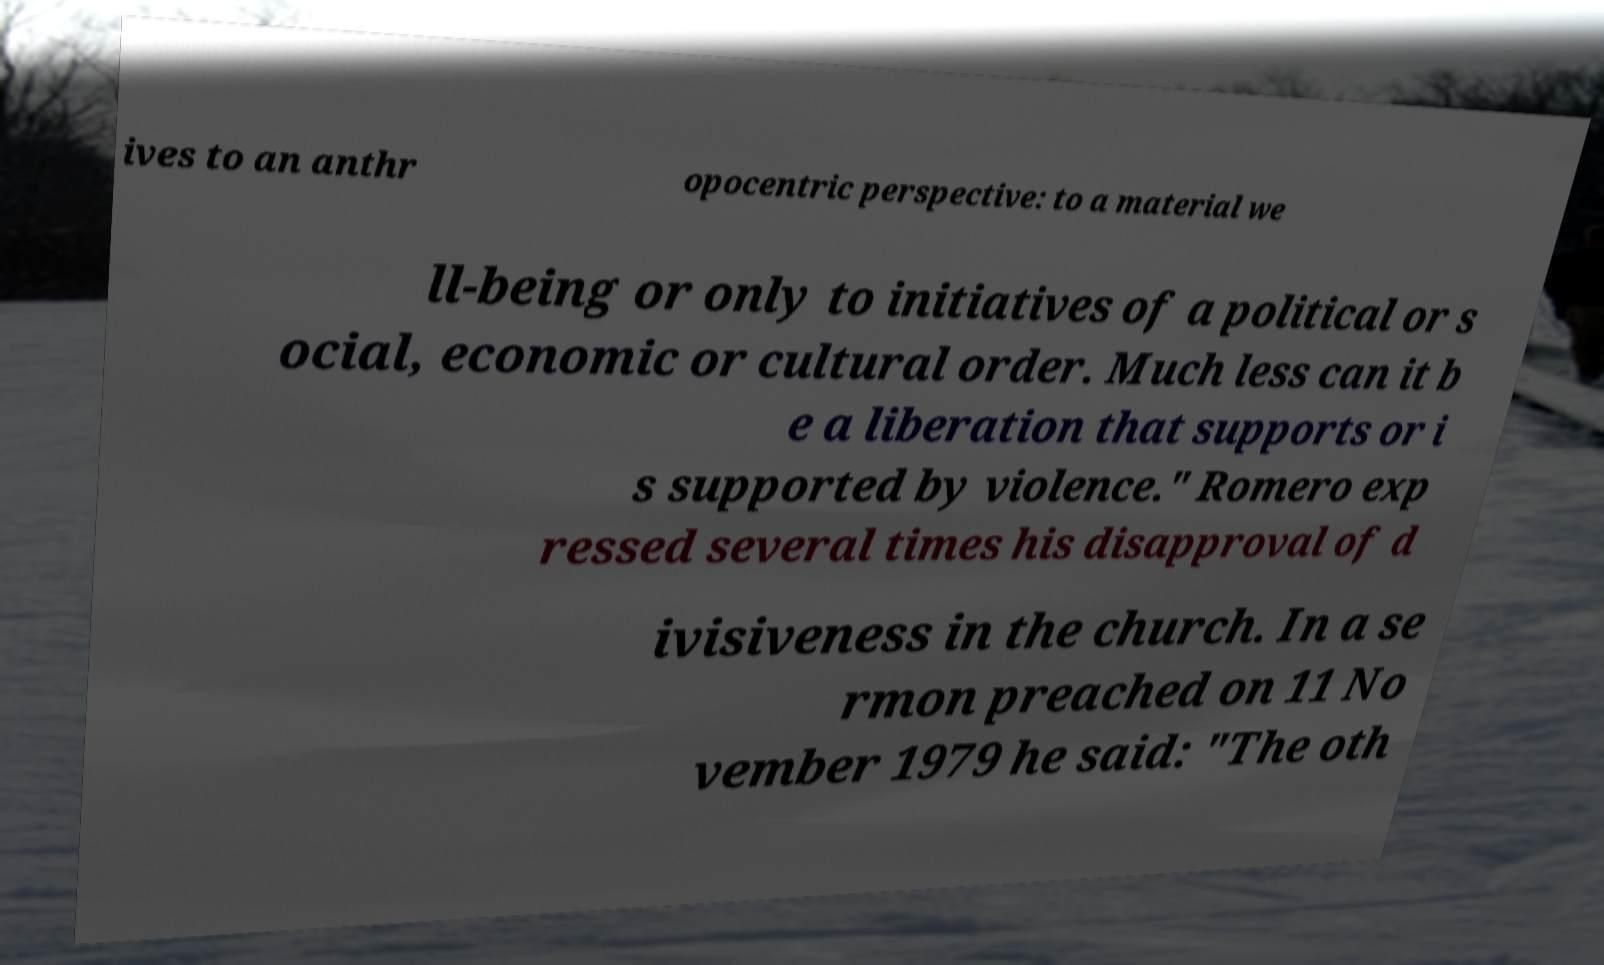Could you extract and type out the text from this image? ives to an anthr opocentric perspective: to a material we ll-being or only to initiatives of a political or s ocial, economic or cultural order. Much less can it b e a liberation that supports or i s supported by violence." Romero exp ressed several times his disapproval of d ivisiveness in the church. In a se rmon preached on 11 No vember 1979 he said: "The oth 